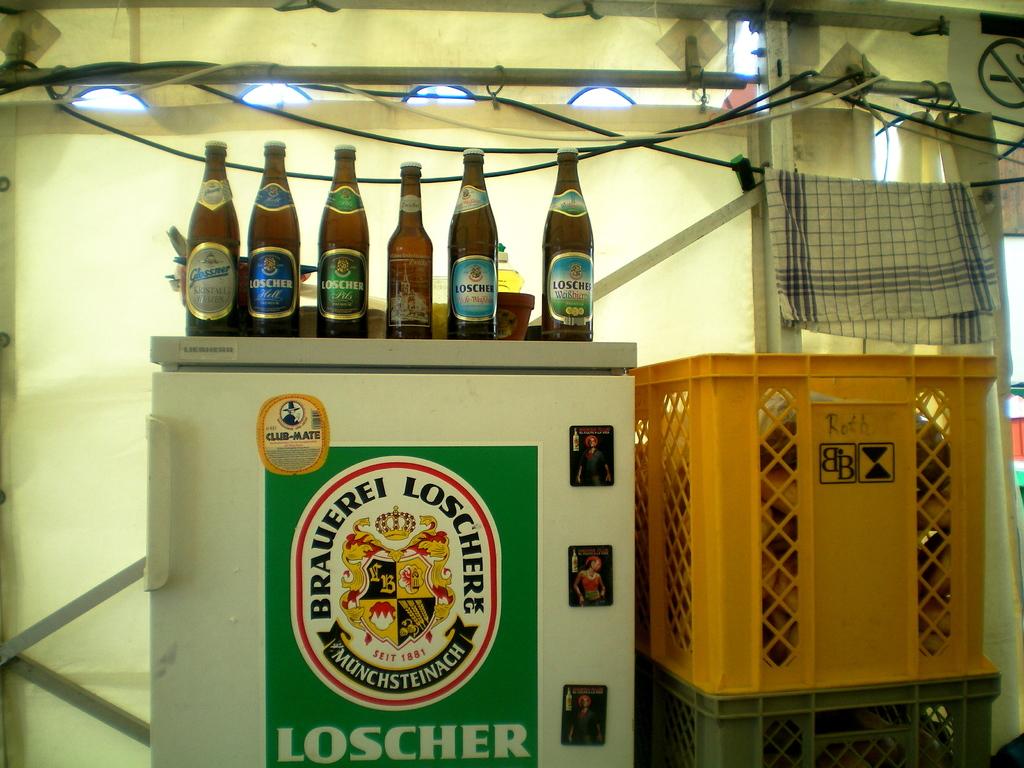What brand of beer is advertised on the green sticker?
Offer a terse response. Loscher. 